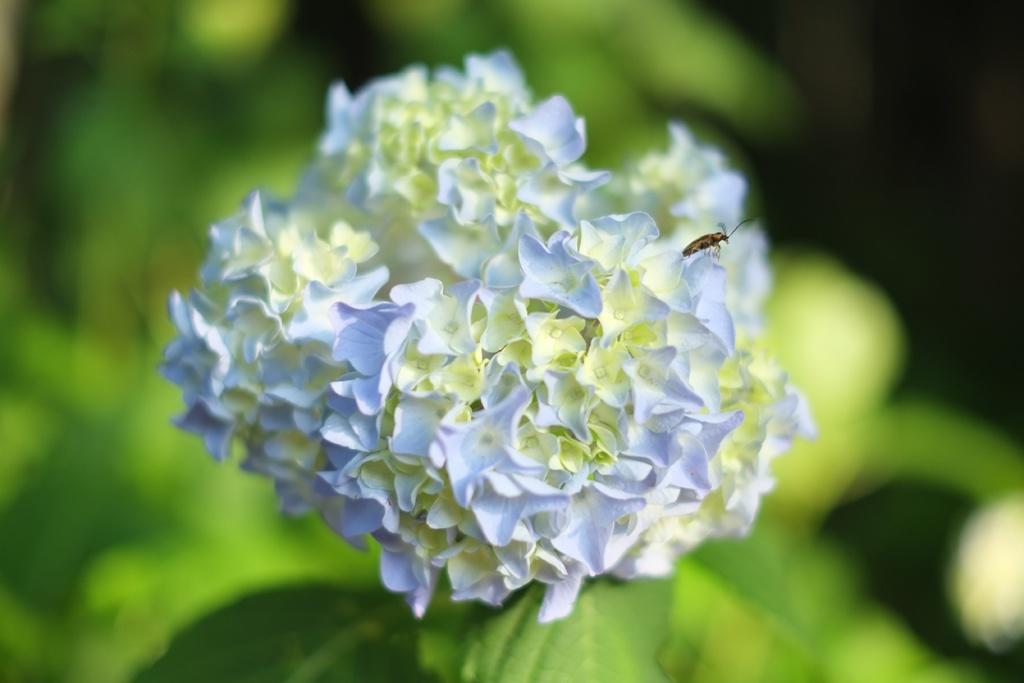What is the main subject of the image? There is an insect in the image. Where is the insect located? The insect is on flowers. Can you describe the background of the image? The background of the image is blurred. What type of vegetation can be seen in the background? There is greenery in the background of the image. What type of substance is the insect holding in its hand in the image? There is no substance visible in the insect's hand, as insects do not have hands. Additionally, there is no indication of any substance in the image. 